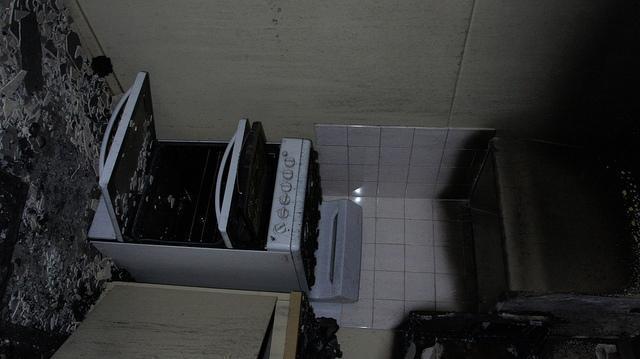How many stairs are in the picture?
Give a very brief answer. 0. How many knobs can be seen on the stove?
Give a very brief answer. 6. 